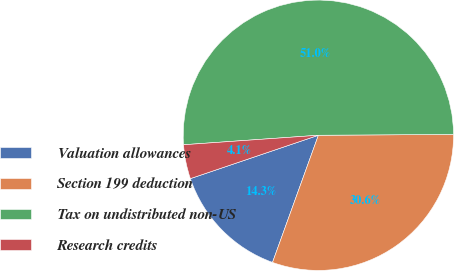<chart> <loc_0><loc_0><loc_500><loc_500><pie_chart><fcel>Valuation allowances<fcel>Section 199 deduction<fcel>Tax on undistributed non-US<fcel>Research credits<nl><fcel>14.29%<fcel>30.61%<fcel>51.02%<fcel>4.08%<nl></chart> 